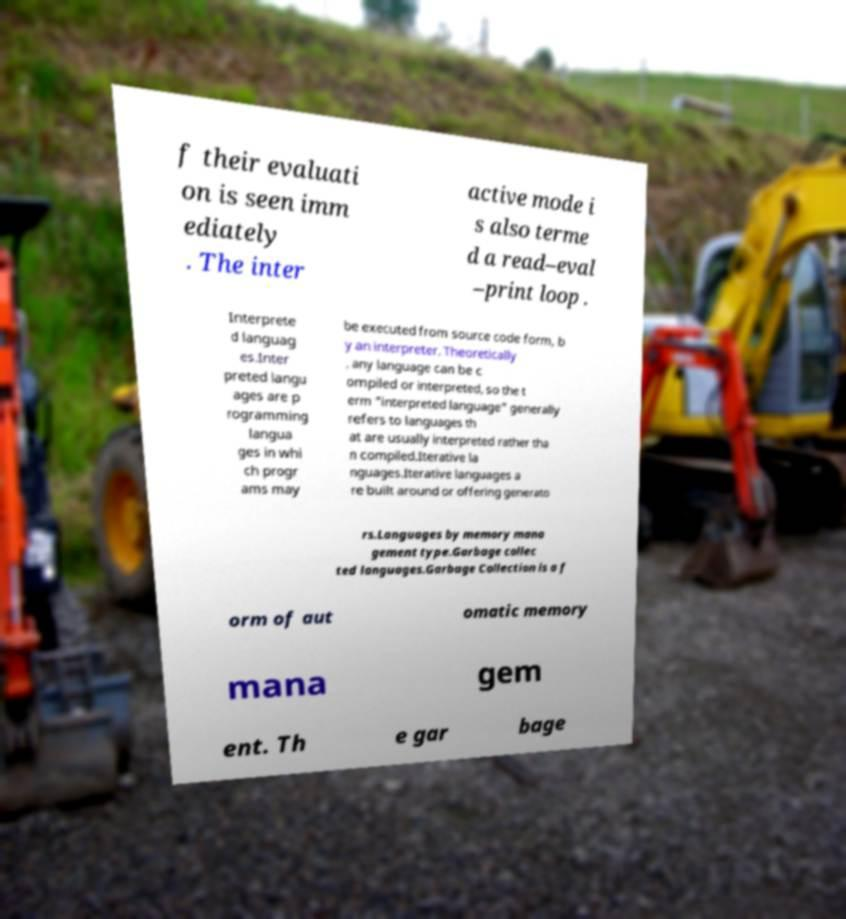Please identify and transcribe the text found in this image. f their evaluati on is seen imm ediately . The inter active mode i s also terme d a read–eval –print loop . Interprete d languag es.Inter preted langu ages are p rogramming langua ges in whi ch progr ams may be executed from source code form, b y an interpreter. Theoretically , any language can be c ompiled or interpreted, so the t erm "interpreted language" generally refers to languages th at are usually interpreted rather tha n compiled.Iterative la nguages.Iterative languages a re built around or offering generato rs.Languages by memory mana gement type.Garbage collec ted languages.Garbage Collection is a f orm of aut omatic memory mana gem ent. Th e gar bage 